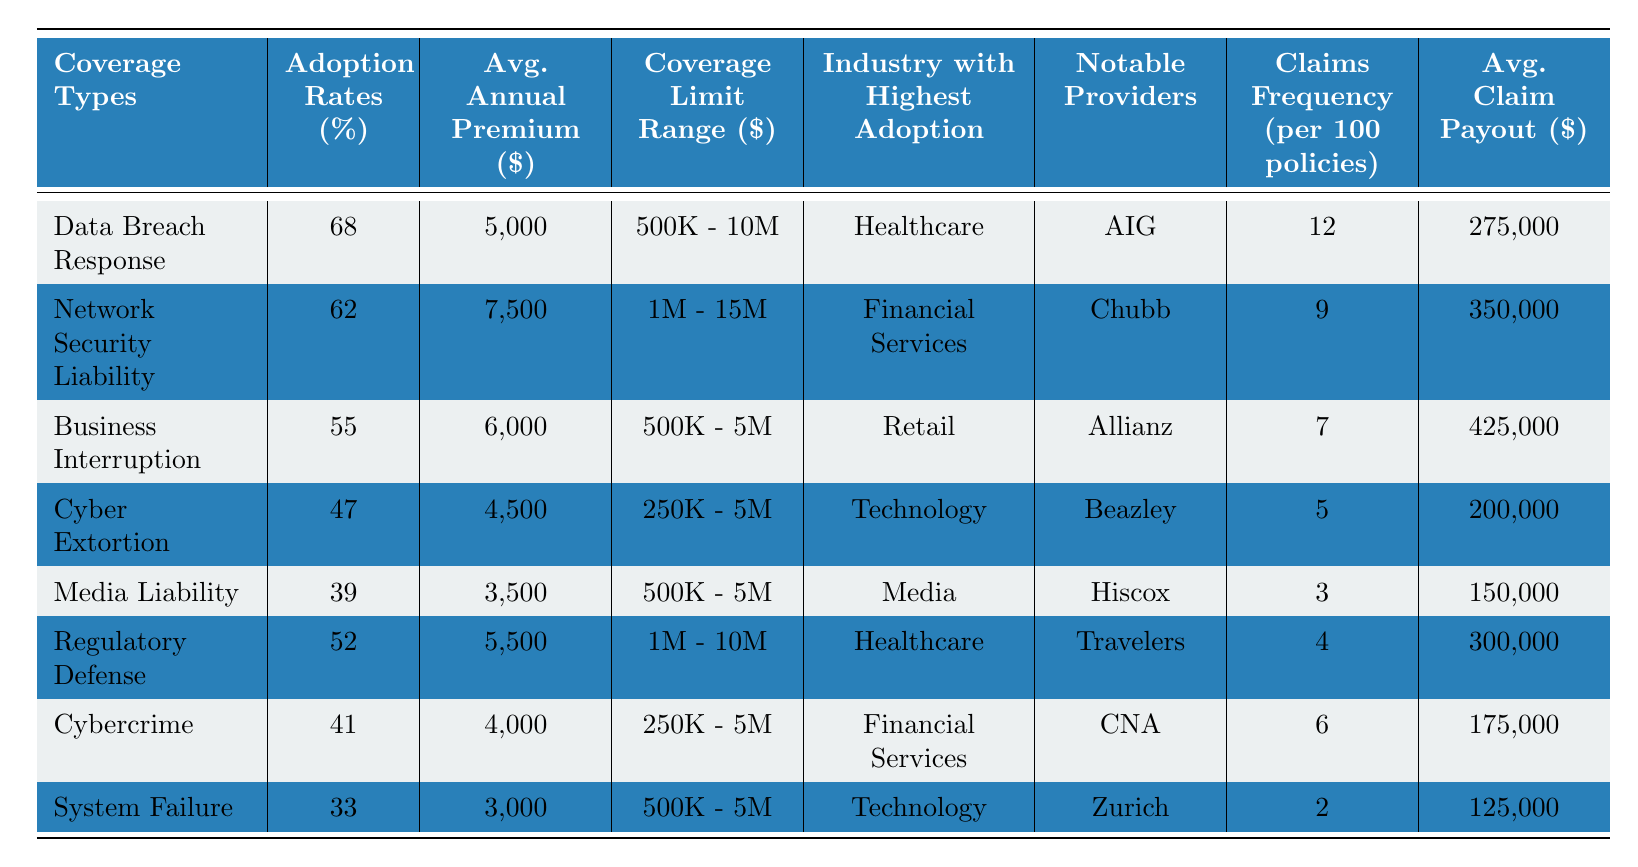What is the adoption rate for Cyber Extortion coverage? The table lists the adoption rate for each coverage type, and for Cyber Extortion, it is explicitly shown as 47%.
Answer: 47% Which coverage type has the highest average claim payout? Looking at the Average Claim Payout column, Business Interruption has the highest value at $425,000 compared to others.
Answer: $425,000 How many coverage types have an adoption rate above 50%? Checking the Adoption Rates column, Data Breach Response (68%) and Network Security Liability (62%) are above 50%, making it a total of 2 types.
Answer: 2 What is the difference in average annual premiums between Media Liability and Cybercrime? The average annual premium for Media Liability is $3,500, and for Cybercrime, it is $4,000. The difference is $4,000 - $3,500 = $500.
Answer: $500 Is it true that the industry with the highest adoption for Business Interruption is Retail? The table indicates that the industry with the highest adoption for Business Interruption is Retail, confirming that the statement is true.
Answer: True What is the average claims frequency across all coverage types? To calculate the average claims frequency, sum all values (12 + 9 + 7 + 5 + 3 + 4 + 6 + 2) = 48, and divide by the number of coverage types (8), resulting in 48 / 8 = 6.
Answer: 6 Which coverage type has the lowest adoption rate and what is it? The lowest adoption rate is for System Failure which has an adoption rate of 33%, as noted in the Adoption Rates column.
Answer: System Failure, 33% How do the average claim payouts for Network Security Liability and Regulatory Defense compare? For Network Security Liability, the average claim payout is $350,000, and for Regulatory Defense, it is $300,000. Network Security Liability has a higher payout by $50,000.
Answer: Network Security Liability is higher by $50,000 What is the combined average annual premium for the top three adopted coverage types? The top three adopted coverage types are Data Breach Response ($5,000), Network Security Liability ($7,500), and Business Interruption ($6,000). The combined average is ($5,000 + $7,500 + $6,000) / 3 = $6,167.
Answer: $6,167 Which notable provider covers the Cybercrime type? The table shows that the notable provider for Cybercrime is CNA.
Answer: CNA 